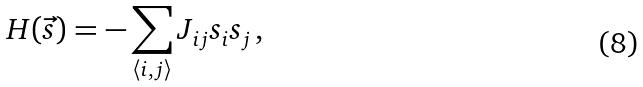Convert formula to latex. <formula><loc_0><loc_0><loc_500><loc_500>H ( \vec { s } ) = - \sum _ { \langle i , j \rangle } J _ { i j } s _ { i } s _ { j } \, ,</formula> 